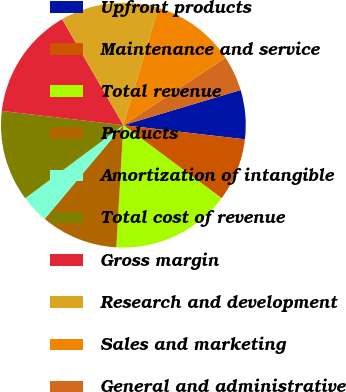Convert chart. <chart><loc_0><loc_0><loc_500><loc_500><pie_chart><fcel>Upfront products<fcel>Maintenance and service<fcel>Total revenue<fcel>Products<fcel>Amortization of intangible<fcel>Total cost of revenue<fcel>Gross margin<fcel>Research and development<fcel>Sales and marketing<fcel>General and administrative<nl><fcel>6.48%<fcel>8.33%<fcel>15.74%<fcel>10.19%<fcel>3.7%<fcel>12.04%<fcel>14.81%<fcel>12.96%<fcel>11.11%<fcel>4.63%<nl></chart> 